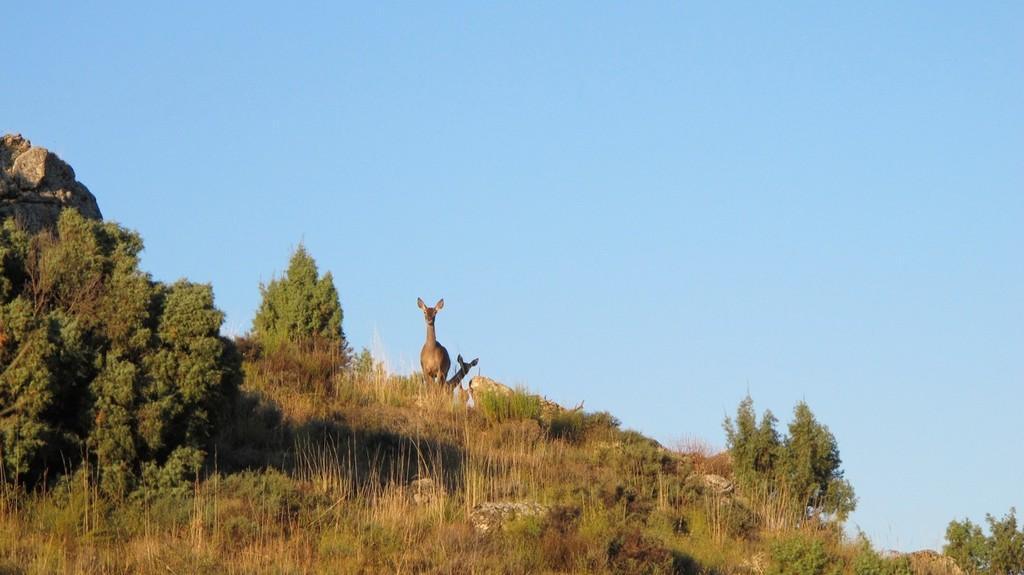Describe this image in one or two sentences. In this image in the center there are two animals and there are some trees, plants and some rocks. At the top of the image there is sky. 